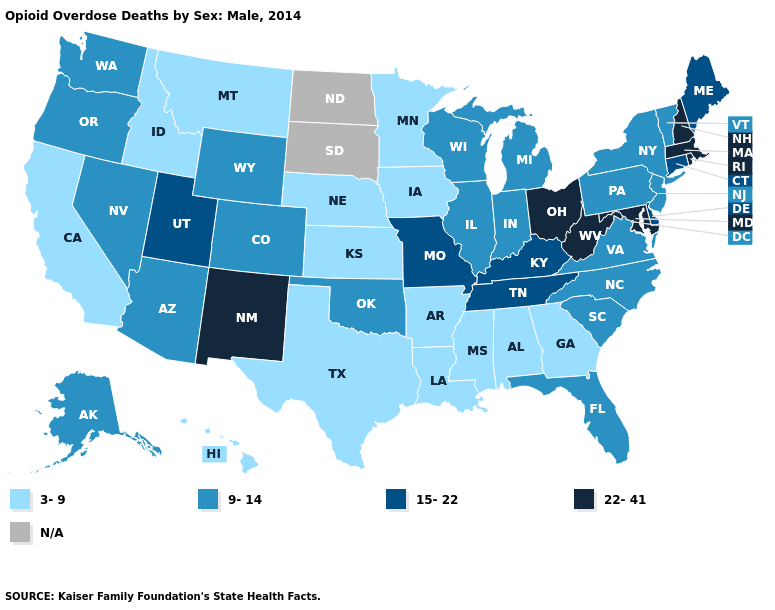What is the value of Montana?
Short answer required. 3-9. Among the states that border Illinois , which have the highest value?
Concise answer only. Kentucky, Missouri. Which states have the lowest value in the USA?
Give a very brief answer. Alabama, Arkansas, California, Georgia, Hawaii, Idaho, Iowa, Kansas, Louisiana, Minnesota, Mississippi, Montana, Nebraska, Texas. Is the legend a continuous bar?
Give a very brief answer. No. Does the map have missing data?
Be succinct. Yes. Which states have the highest value in the USA?
Quick response, please. Maryland, Massachusetts, New Hampshire, New Mexico, Ohio, Rhode Island, West Virginia. Name the states that have a value in the range 22-41?
Answer briefly. Maryland, Massachusetts, New Hampshire, New Mexico, Ohio, Rhode Island, West Virginia. Among the states that border Missouri , does Iowa have the lowest value?
Concise answer only. Yes. Among the states that border Maryland , does Pennsylvania have the highest value?
Quick response, please. No. Among the states that border Massachusetts , which have the lowest value?
Answer briefly. New York, Vermont. What is the value of Wyoming?
Quick response, please. 9-14. Does Pennsylvania have the lowest value in the USA?
Concise answer only. No. How many symbols are there in the legend?
Keep it brief. 5. Name the states that have a value in the range 9-14?
Short answer required. Alaska, Arizona, Colorado, Florida, Illinois, Indiana, Michigan, Nevada, New Jersey, New York, North Carolina, Oklahoma, Oregon, Pennsylvania, South Carolina, Vermont, Virginia, Washington, Wisconsin, Wyoming. 